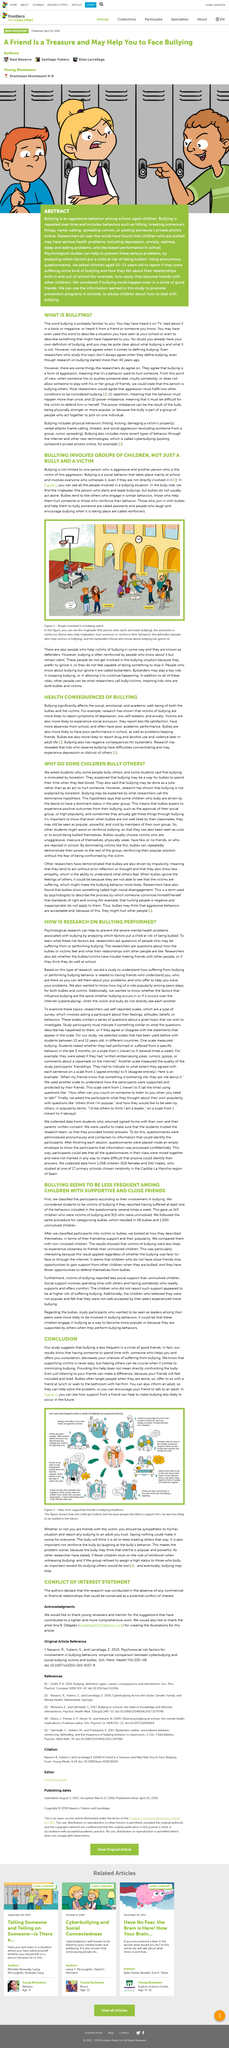Indicate a few pertinent items in this graphic. In the study that found bullying to be less frequent among children with supportive and close friends, a total of 1058 children were included. In the study, 143 children were identified as victims of bullying. The study concludes that psychological research can help prevent the severe mental health problems associated with bullying. The requirement to be considered a victim of bullying was that children had to report having suffered at least one of the behaviors included in the questionnaire several times a week. In the article, the researchers pose the question of whether the bullies and victims believe that they are successful in school. 